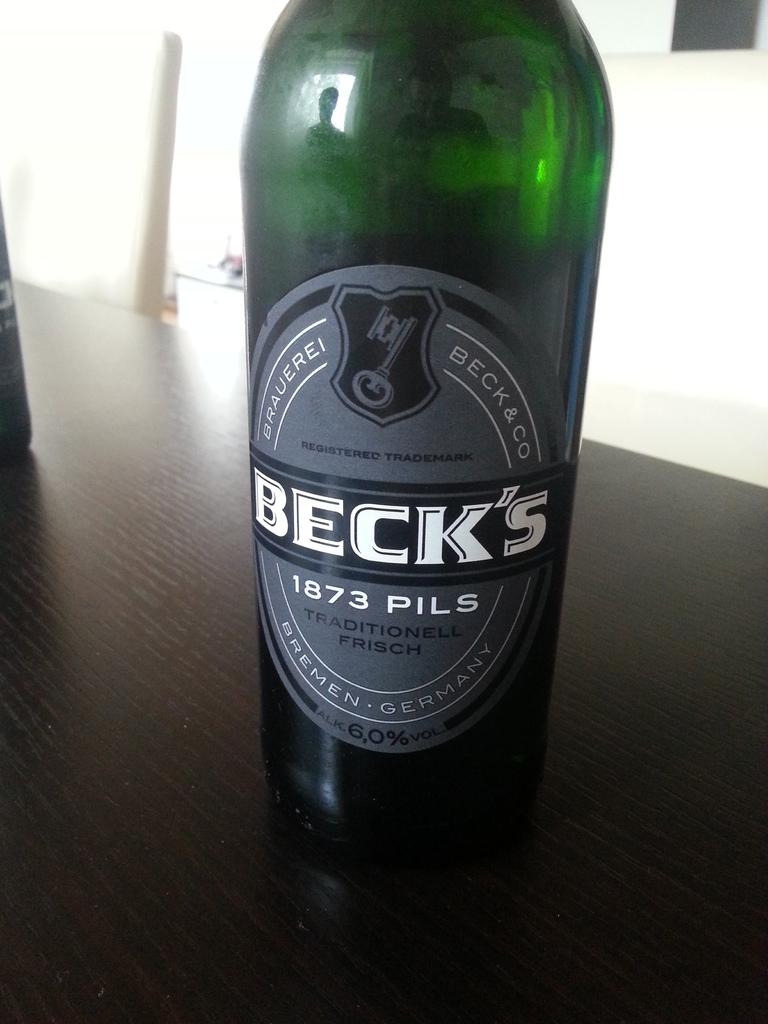<image>
Create a compact narrative representing the image presented. A close up of a Becks 1873 Pils label which is grey on a bottle of lager. 